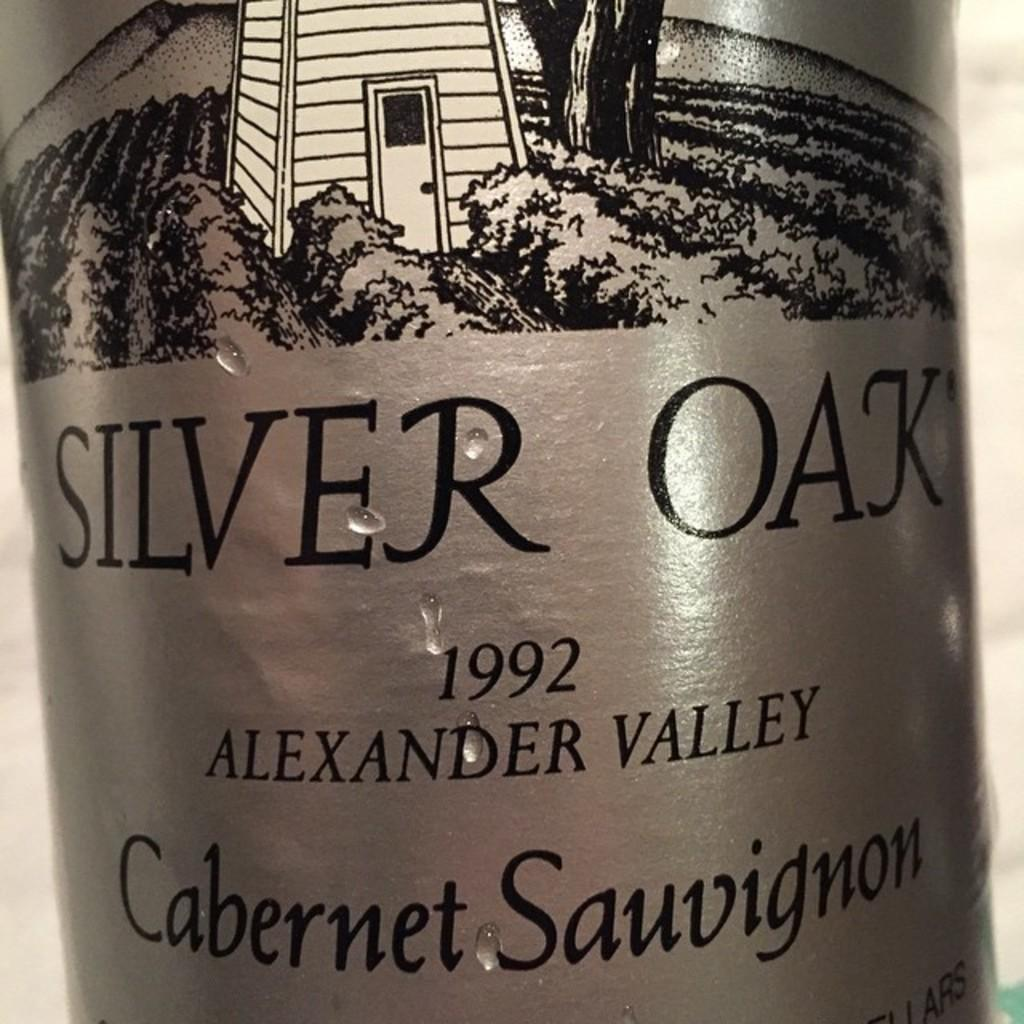<image>
Provide a brief description of the given image. the label for SILVER OAK 1992 ALEXANDER VALLEY Cabernet Sauvignon LIQUOR. 